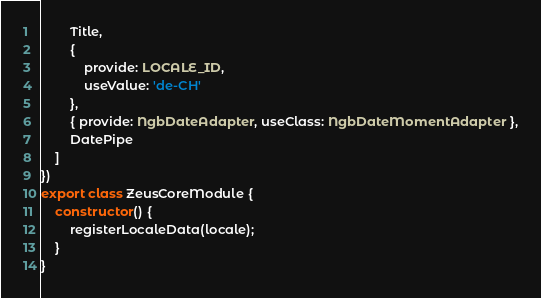<code> <loc_0><loc_0><loc_500><loc_500><_TypeScript_>        Title,
        {
            provide: LOCALE_ID,
            useValue: 'de-CH'
        },
        { provide: NgbDateAdapter, useClass: NgbDateMomentAdapter },
        DatePipe
    ]
})
export class ZeusCoreModule {
    constructor() {
        registerLocaleData(locale);
    }
}
</code> 